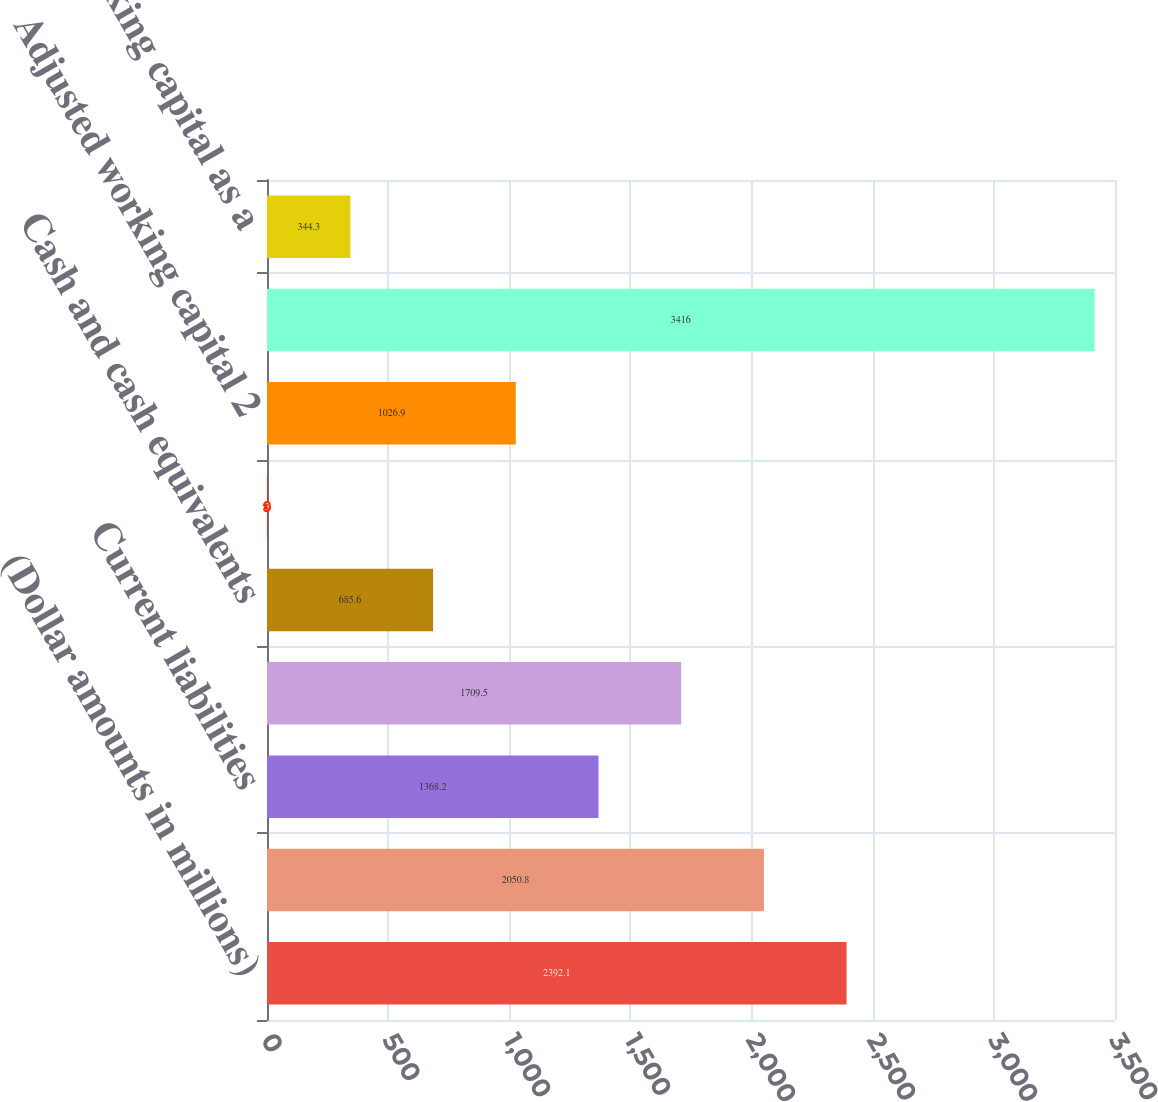Convert chart. <chart><loc_0><loc_0><loc_500><loc_500><bar_chart><fcel>(Dollar amounts in millions)<fcel>Current assets<fcel>Current liabilities<fcel>Working capital<fcel>Cash and cash equivalents<fcel>Current debt maturities<fcel>Adjusted working capital 2<fcel>Annualized sales 1<fcel>Adjusted working capital as a<nl><fcel>2392.1<fcel>2050.8<fcel>1368.2<fcel>1709.5<fcel>685.6<fcel>3<fcel>1026.9<fcel>3416<fcel>344.3<nl></chart> 